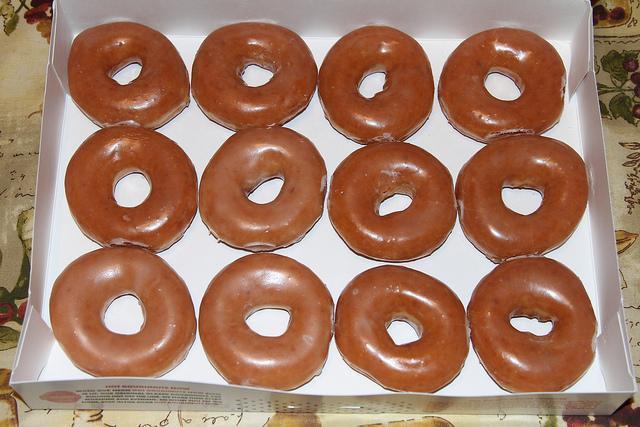How many donuts are visible?
Give a very brief answer. 12. 